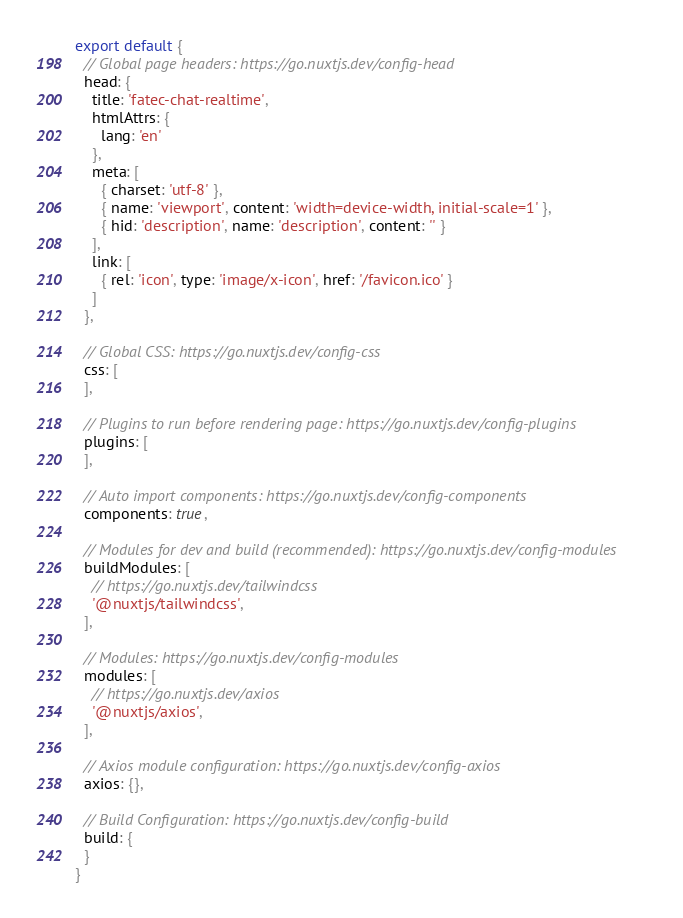<code> <loc_0><loc_0><loc_500><loc_500><_JavaScript_>export default {
  // Global page headers: https://go.nuxtjs.dev/config-head
  head: {
    title: 'fatec-chat-realtime',
    htmlAttrs: {
      lang: 'en'
    },
    meta: [
      { charset: 'utf-8' },
      { name: 'viewport', content: 'width=device-width, initial-scale=1' },
      { hid: 'description', name: 'description', content: '' }
    ],
    link: [
      { rel: 'icon', type: 'image/x-icon', href: '/favicon.ico' }
    ]
  },

  // Global CSS: https://go.nuxtjs.dev/config-css
  css: [
  ],

  // Plugins to run before rendering page: https://go.nuxtjs.dev/config-plugins
  plugins: [
  ],

  // Auto import components: https://go.nuxtjs.dev/config-components
  components: true,

  // Modules for dev and build (recommended): https://go.nuxtjs.dev/config-modules
  buildModules: [
    // https://go.nuxtjs.dev/tailwindcss
    '@nuxtjs/tailwindcss',
  ],

  // Modules: https://go.nuxtjs.dev/config-modules
  modules: [
    // https://go.nuxtjs.dev/axios
    '@nuxtjs/axios',
  ],

  // Axios module configuration: https://go.nuxtjs.dev/config-axios
  axios: {},

  // Build Configuration: https://go.nuxtjs.dev/config-build
  build: {
  }
}
</code> 